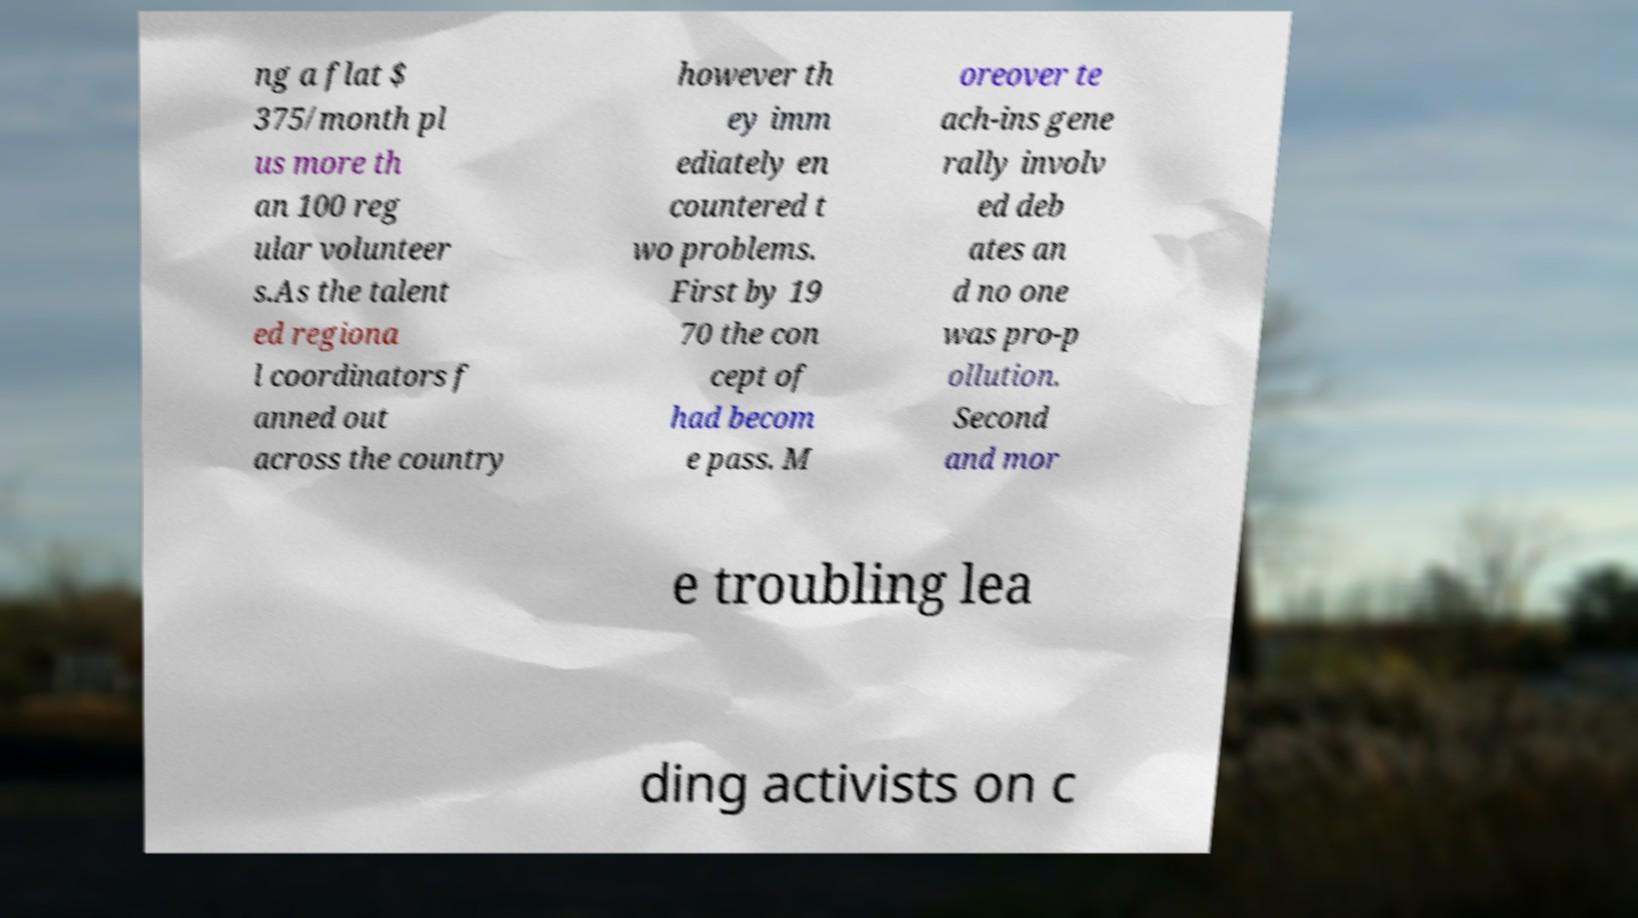What messages or text are displayed in this image? I need them in a readable, typed format. ng a flat $ 375/month pl us more th an 100 reg ular volunteer s.As the talent ed regiona l coordinators f anned out across the country however th ey imm ediately en countered t wo problems. First by 19 70 the con cept of had becom e pass. M oreover te ach-ins gene rally involv ed deb ates an d no one was pro-p ollution. Second and mor e troubling lea ding activists on c 